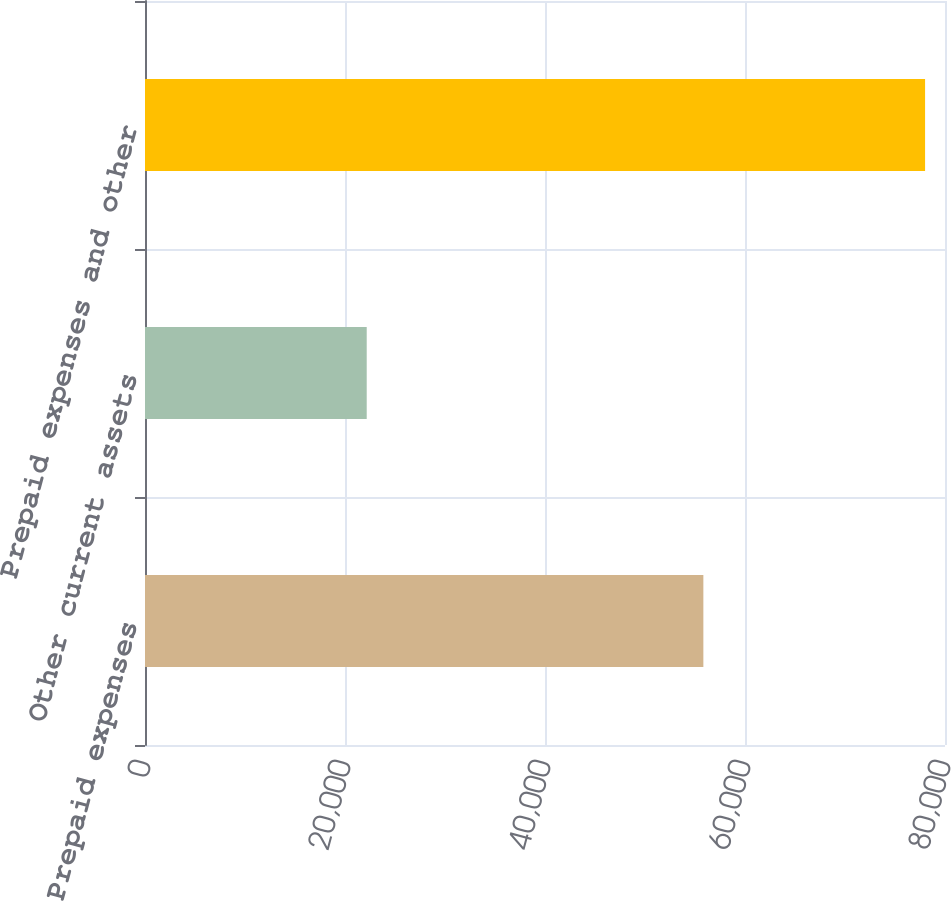Convert chart. <chart><loc_0><loc_0><loc_500><loc_500><bar_chart><fcel>Prepaid expenses<fcel>Other current assets<fcel>Prepaid expenses and other<nl><fcel>55836<fcel>22172<fcel>78008<nl></chart> 